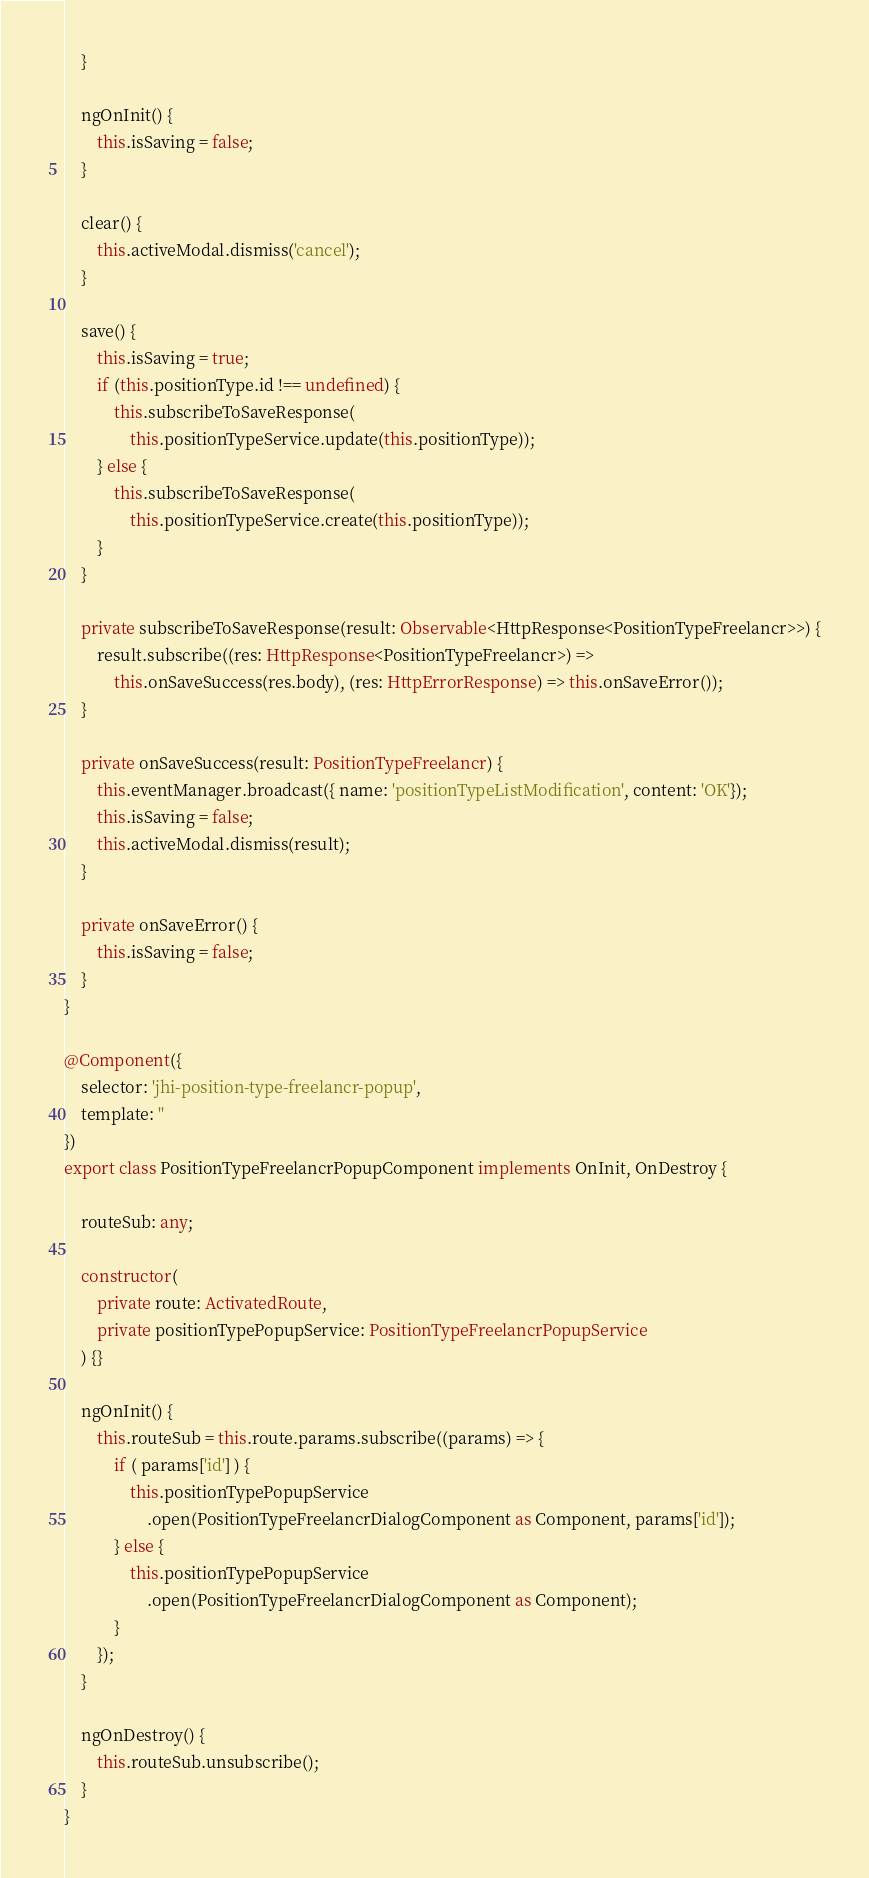<code> <loc_0><loc_0><loc_500><loc_500><_TypeScript_>    }

    ngOnInit() {
        this.isSaving = false;
    }

    clear() {
        this.activeModal.dismiss('cancel');
    }

    save() {
        this.isSaving = true;
        if (this.positionType.id !== undefined) {
            this.subscribeToSaveResponse(
                this.positionTypeService.update(this.positionType));
        } else {
            this.subscribeToSaveResponse(
                this.positionTypeService.create(this.positionType));
        }
    }

    private subscribeToSaveResponse(result: Observable<HttpResponse<PositionTypeFreelancr>>) {
        result.subscribe((res: HttpResponse<PositionTypeFreelancr>) =>
            this.onSaveSuccess(res.body), (res: HttpErrorResponse) => this.onSaveError());
    }

    private onSaveSuccess(result: PositionTypeFreelancr) {
        this.eventManager.broadcast({ name: 'positionTypeListModification', content: 'OK'});
        this.isSaving = false;
        this.activeModal.dismiss(result);
    }

    private onSaveError() {
        this.isSaving = false;
    }
}

@Component({
    selector: 'jhi-position-type-freelancr-popup',
    template: ''
})
export class PositionTypeFreelancrPopupComponent implements OnInit, OnDestroy {

    routeSub: any;

    constructor(
        private route: ActivatedRoute,
        private positionTypePopupService: PositionTypeFreelancrPopupService
    ) {}

    ngOnInit() {
        this.routeSub = this.route.params.subscribe((params) => {
            if ( params['id'] ) {
                this.positionTypePopupService
                    .open(PositionTypeFreelancrDialogComponent as Component, params['id']);
            } else {
                this.positionTypePopupService
                    .open(PositionTypeFreelancrDialogComponent as Component);
            }
        });
    }

    ngOnDestroy() {
        this.routeSub.unsubscribe();
    }
}
</code> 